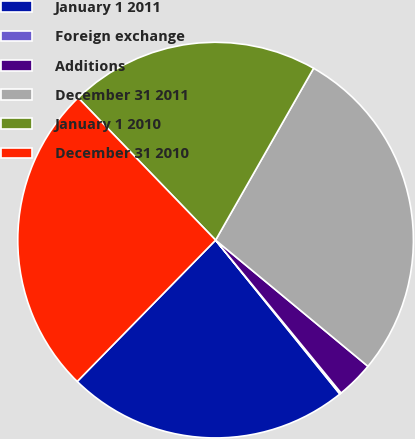Convert chart. <chart><loc_0><loc_0><loc_500><loc_500><pie_chart><fcel>January 1 2011<fcel>Foreign exchange<fcel>Additions<fcel>December 31 2011<fcel>January 1 2010<fcel>December 31 2010<nl><fcel>23.14%<fcel>0.13%<fcel>3.05%<fcel>27.76%<fcel>20.47%<fcel>25.45%<nl></chart> 